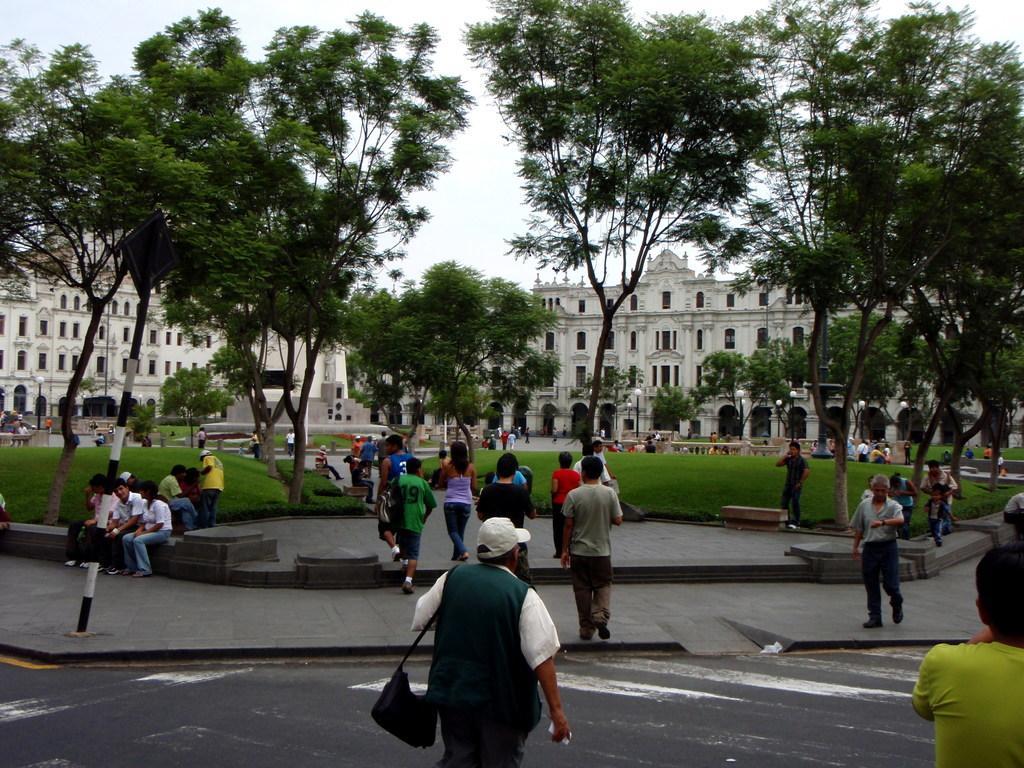In one or two sentences, can you explain what this image depicts? In this picture I can see at the bottom a group of people are there, in the middle there are trees, in the background there are buildings. At the top there is the sky. 